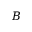Convert formula to latex. <formula><loc_0><loc_0><loc_500><loc_500>B</formula> 